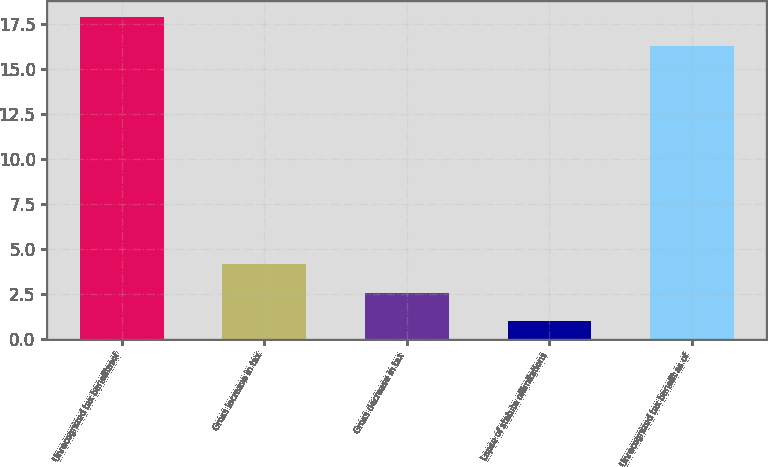<chart> <loc_0><loc_0><loc_500><loc_500><bar_chart><fcel>Unrecognized tax benefitasof<fcel>Gross increase in tax<fcel>Gross decrease in tax<fcel>Lapse of statute oflimitations<fcel>Unrecognized tax benefit as of<nl><fcel>17.88<fcel>4.16<fcel>2.58<fcel>1<fcel>16.3<nl></chart> 